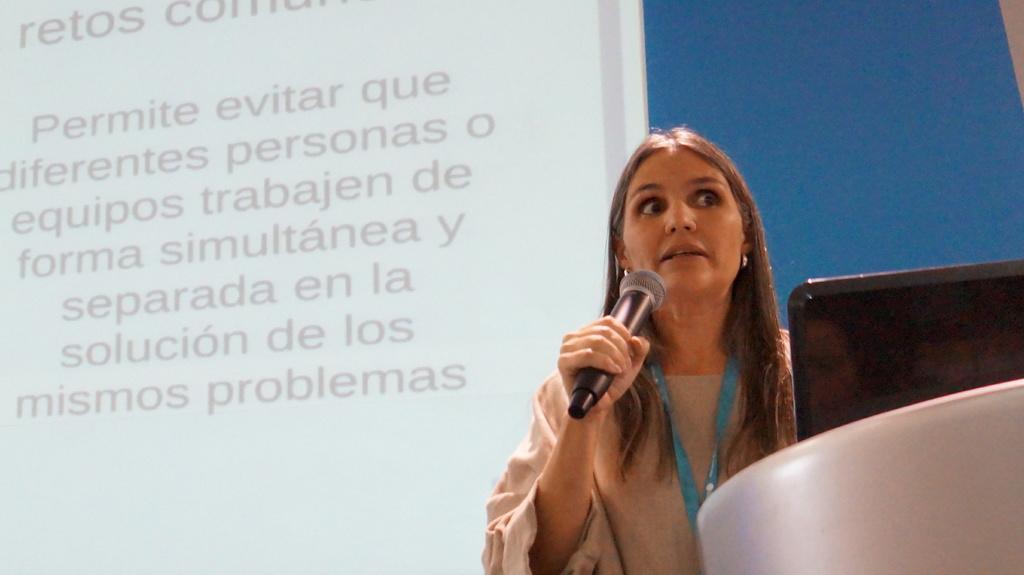In one or two sentences, can you explain what this image depicts? In this picture there is a woman standing and holding a microphone and we can see objects. In the background of the image we can see screen. 